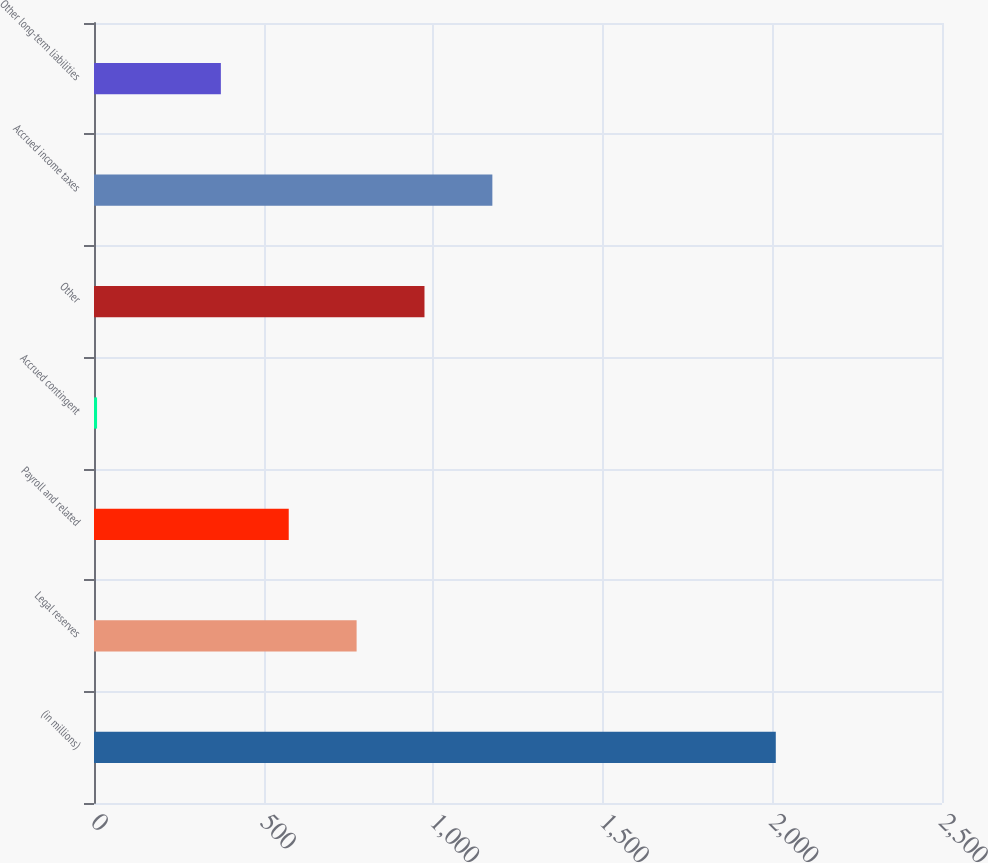Convert chart to OTSL. <chart><loc_0><loc_0><loc_500><loc_500><bar_chart><fcel>(in millions)<fcel>Legal reserves<fcel>Payroll and related<fcel>Accrued contingent<fcel>Other<fcel>Accrued income taxes<fcel>Other long-term liabilities<nl><fcel>2010<fcel>774.2<fcel>574.1<fcel>9<fcel>974.3<fcel>1174.4<fcel>374<nl></chart> 